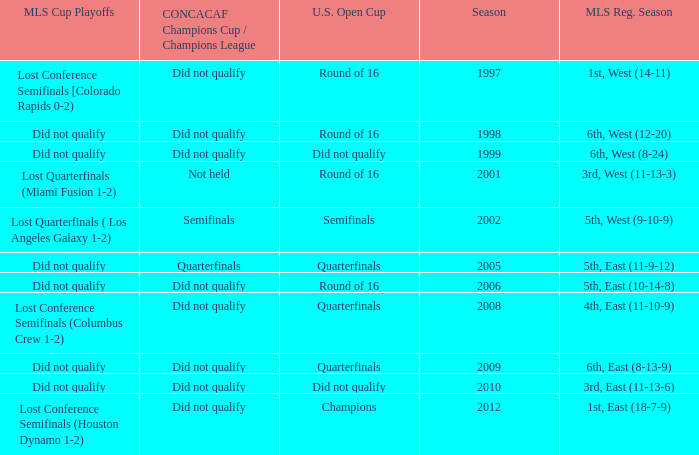When was the first season? 1997.0. 